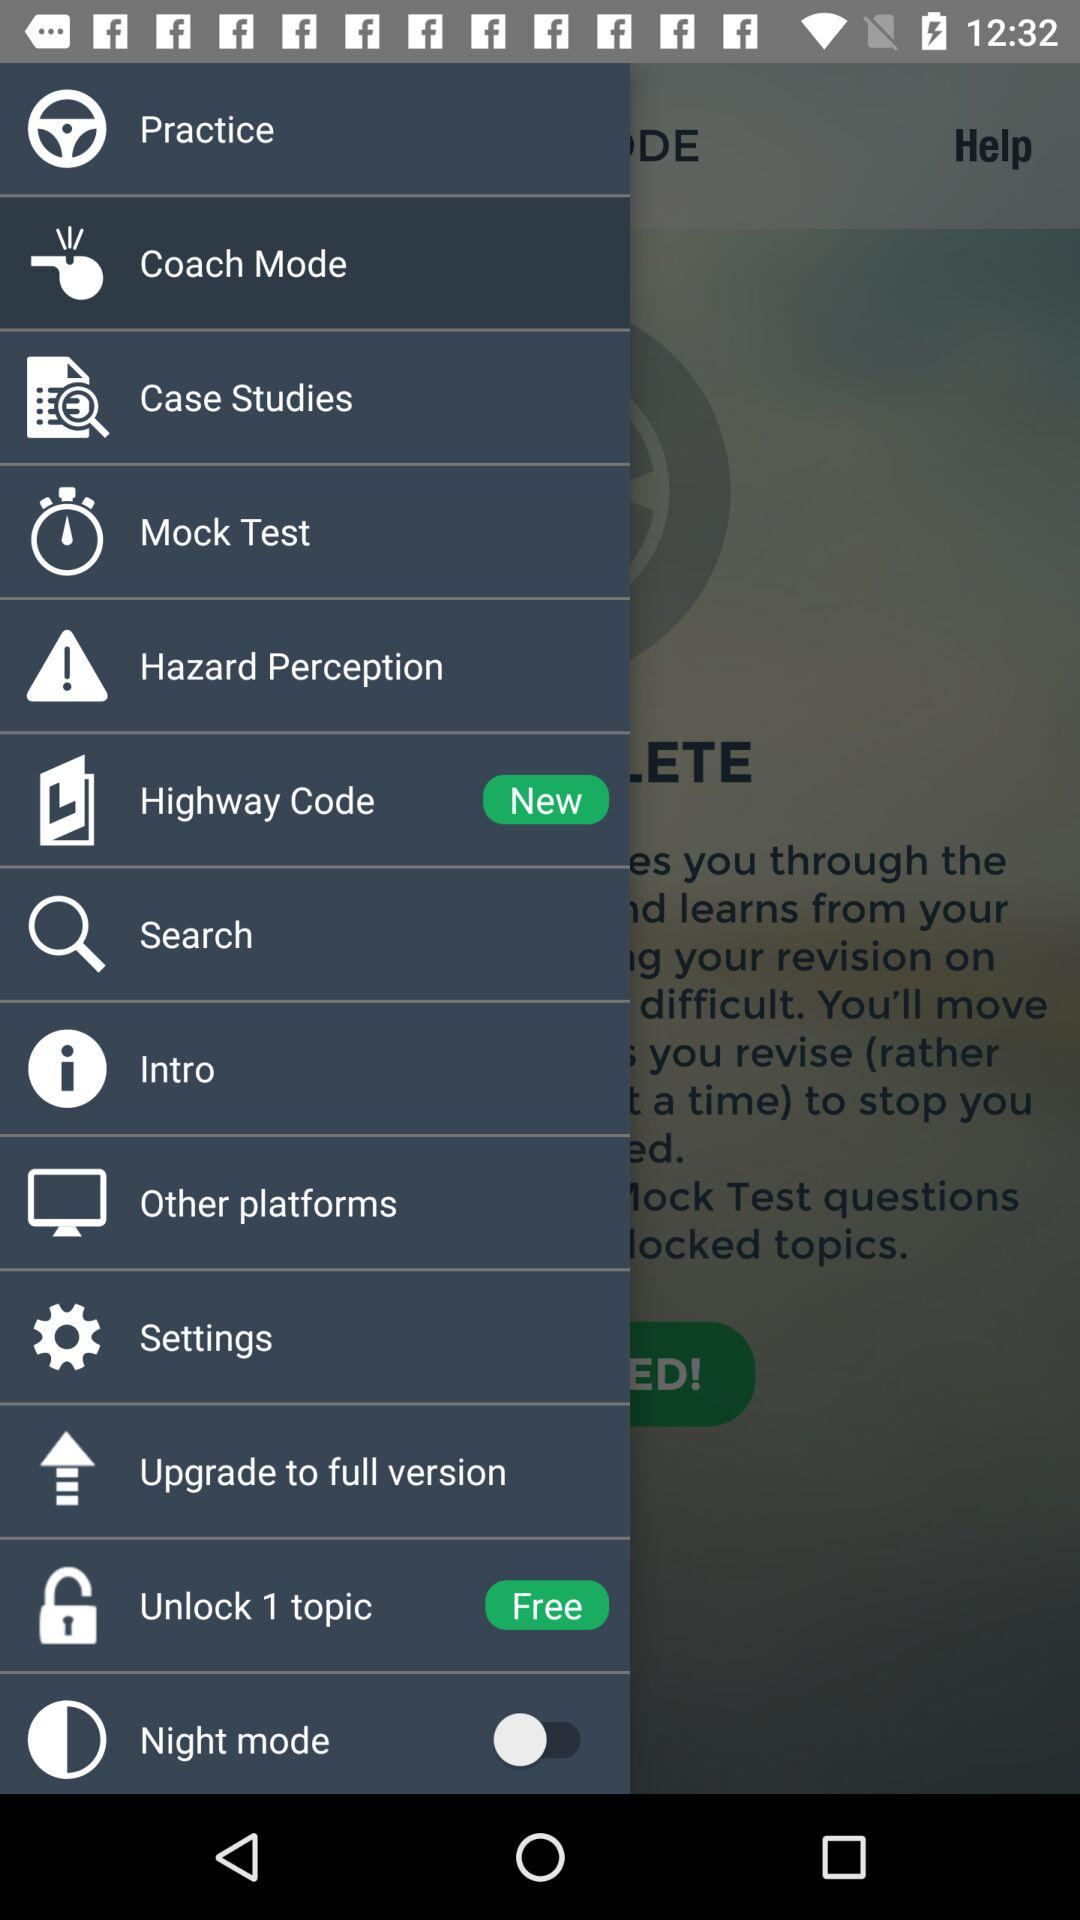Which item is new? The new item is "Highway Code". 